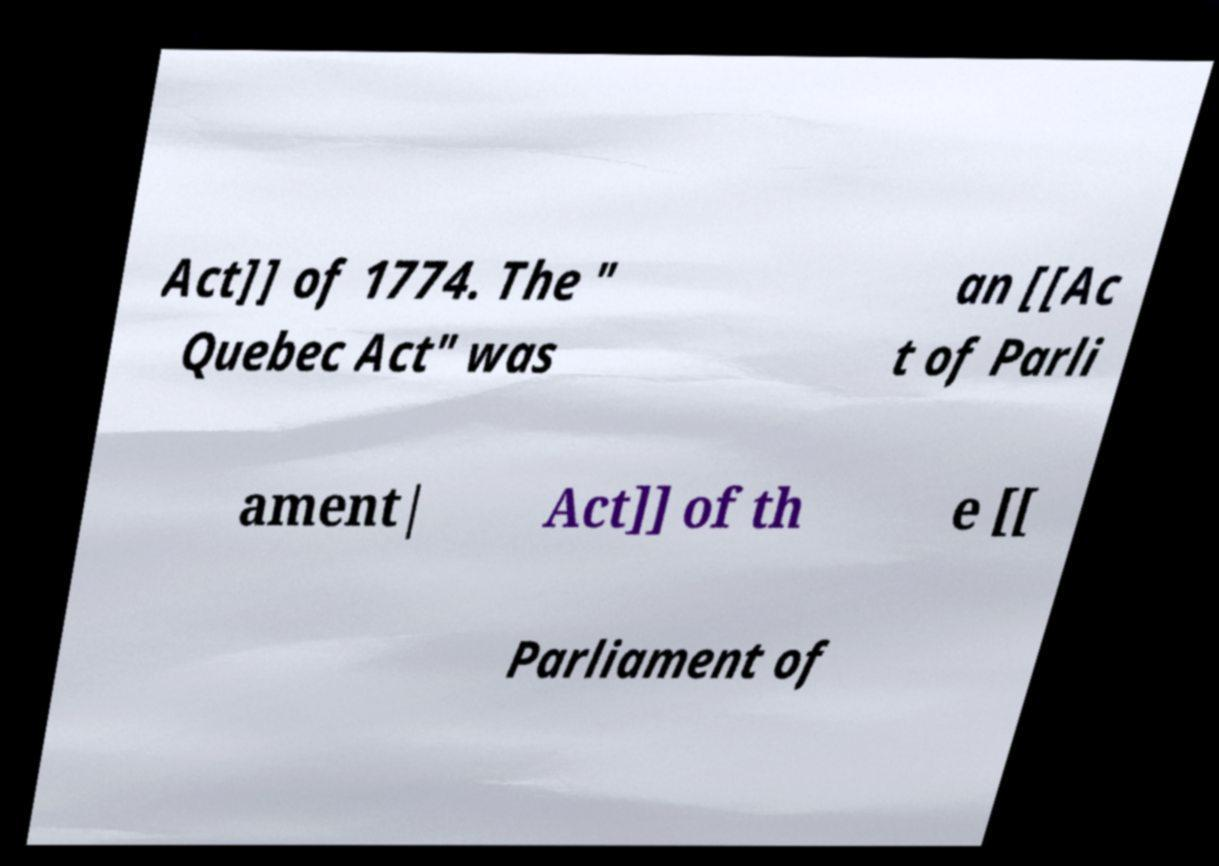Can you accurately transcribe the text from the provided image for me? Act]] of 1774. The " Quebec Act" was an [[Ac t of Parli ament| Act]] of th e [[ Parliament of 